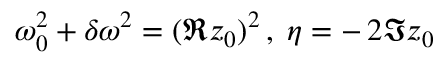<formula> <loc_0><loc_0><loc_500><loc_500>\, \omega _ { 0 } ^ { 2 } + \delta \omega ^ { 2 } = ( \Re z _ { 0 } ) ^ { 2 } \, , \, \eta = - \, 2 \Im z _ { 0 } \,</formula> 